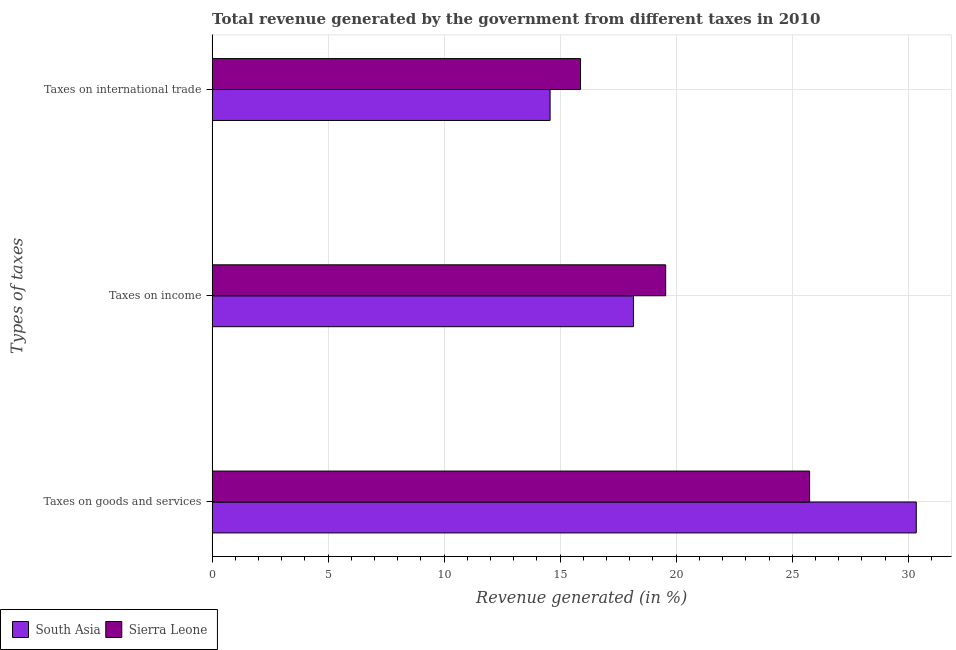How many bars are there on the 3rd tick from the top?
Ensure brevity in your answer.  2. How many bars are there on the 1st tick from the bottom?
Ensure brevity in your answer.  2. What is the label of the 1st group of bars from the top?
Your answer should be very brief. Taxes on international trade. What is the percentage of revenue generated by tax on international trade in South Asia?
Keep it short and to the point. 14.57. Across all countries, what is the maximum percentage of revenue generated by tax on international trade?
Your response must be concise. 15.88. Across all countries, what is the minimum percentage of revenue generated by taxes on income?
Give a very brief answer. 18.16. In which country was the percentage of revenue generated by taxes on income maximum?
Offer a very short reply. Sierra Leone. In which country was the percentage of revenue generated by tax on international trade minimum?
Provide a succinct answer. South Asia. What is the total percentage of revenue generated by tax on international trade in the graph?
Provide a short and direct response. 30.44. What is the difference between the percentage of revenue generated by tax on international trade in South Asia and that in Sierra Leone?
Provide a short and direct response. -1.31. What is the difference between the percentage of revenue generated by taxes on income in South Asia and the percentage of revenue generated by tax on international trade in Sierra Leone?
Give a very brief answer. 2.28. What is the average percentage of revenue generated by taxes on income per country?
Your response must be concise. 18.85. What is the difference between the percentage of revenue generated by tax on international trade and percentage of revenue generated by taxes on goods and services in South Asia?
Provide a short and direct response. -15.78. In how many countries, is the percentage of revenue generated by taxes on income greater than 4 %?
Make the answer very short. 2. What is the ratio of the percentage of revenue generated by taxes on income in Sierra Leone to that in South Asia?
Your answer should be compact. 1.08. What is the difference between the highest and the second highest percentage of revenue generated by tax on international trade?
Make the answer very short. 1.31. What is the difference between the highest and the lowest percentage of revenue generated by taxes on goods and services?
Offer a terse response. 4.6. What does the 1st bar from the top in Taxes on income represents?
Ensure brevity in your answer.  Sierra Leone. What does the 1st bar from the bottom in Taxes on goods and services represents?
Offer a terse response. South Asia. How many bars are there?
Offer a very short reply. 6. How many countries are there in the graph?
Your answer should be compact. 2. Does the graph contain grids?
Give a very brief answer. Yes. What is the title of the graph?
Make the answer very short. Total revenue generated by the government from different taxes in 2010. Does "Yemen, Rep." appear as one of the legend labels in the graph?
Your answer should be compact. No. What is the label or title of the X-axis?
Your response must be concise. Revenue generated (in %). What is the label or title of the Y-axis?
Provide a short and direct response. Types of taxes. What is the Revenue generated (in %) of South Asia in Taxes on goods and services?
Offer a very short reply. 30.35. What is the Revenue generated (in %) in Sierra Leone in Taxes on goods and services?
Offer a terse response. 25.75. What is the Revenue generated (in %) in South Asia in Taxes on income?
Keep it short and to the point. 18.16. What is the Revenue generated (in %) in Sierra Leone in Taxes on income?
Provide a succinct answer. 19.55. What is the Revenue generated (in %) of South Asia in Taxes on international trade?
Provide a short and direct response. 14.57. What is the Revenue generated (in %) of Sierra Leone in Taxes on international trade?
Ensure brevity in your answer.  15.88. Across all Types of taxes, what is the maximum Revenue generated (in %) in South Asia?
Keep it short and to the point. 30.35. Across all Types of taxes, what is the maximum Revenue generated (in %) of Sierra Leone?
Your answer should be very brief. 25.75. Across all Types of taxes, what is the minimum Revenue generated (in %) of South Asia?
Provide a short and direct response. 14.57. Across all Types of taxes, what is the minimum Revenue generated (in %) of Sierra Leone?
Provide a succinct answer. 15.88. What is the total Revenue generated (in %) of South Asia in the graph?
Provide a succinct answer. 63.07. What is the total Revenue generated (in %) of Sierra Leone in the graph?
Make the answer very short. 61.17. What is the difference between the Revenue generated (in %) in South Asia in Taxes on goods and services and that in Taxes on income?
Your response must be concise. 12.19. What is the difference between the Revenue generated (in %) in Sierra Leone in Taxes on goods and services and that in Taxes on income?
Offer a very short reply. 6.2. What is the difference between the Revenue generated (in %) of South Asia in Taxes on goods and services and that in Taxes on international trade?
Ensure brevity in your answer.  15.78. What is the difference between the Revenue generated (in %) in Sierra Leone in Taxes on goods and services and that in Taxes on international trade?
Make the answer very short. 9.87. What is the difference between the Revenue generated (in %) in South Asia in Taxes on income and that in Taxes on international trade?
Keep it short and to the point. 3.59. What is the difference between the Revenue generated (in %) in Sierra Leone in Taxes on income and that in Taxes on international trade?
Provide a short and direct response. 3.67. What is the difference between the Revenue generated (in %) in South Asia in Taxes on goods and services and the Revenue generated (in %) in Sierra Leone in Taxes on income?
Your answer should be compact. 10.8. What is the difference between the Revenue generated (in %) of South Asia in Taxes on goods and services and the Revenue generated (in %) of Sierra Leone in Taxes on international trade?
Offer a terse response. 14.47. What is the difference between the Revenue generated (in %) in South Asia in Taxes on income and the Revenue generated (in %) in Sierra Leone in Taxes on international trade?
Provide a short and direct response. 2.28. What is the average Revenue generated (in %) in South Asia per Types of taxes?
Make the answer very short. 21.02. What is the average Revenue generated (in %) of Sierra Leone per Types of taxes?
Your answer should be compact. 20.39. What is the difference between the Revenue generated (in %) in South Asia and Revenue generated (in %) in Sierra Leone in Taxes on goods and services?
Make the answer very short. 4.6. What is the difference between the Revenue generated (in %) in South Asia and Revenue generated (in %) in Sierra Leone in Taxes on income?
Make the answer very short. -1.39. What is the difference between the Revenue generated (in %) of South Asia and Revenue generated (in %) of Sierra Leone in Taxes on international trade?
Keep it short and to the point. -1.31. What is the ratio of the Revenue generated (in %) in South Asia in Taxes on goods and services to that in Taxes on income?
Offer a very short reply. 1.67. What is the ratio of the Revenue generated (in %) of Sierra Leone in Taxes on goods and services to that in Taxes on income?
Your answer should be very brief. 1.32. What is the ratio of the Revenue generated (in %) of South Asia in Taxes on goods and services to that in Taxes on international trade?
Provide a succinct answer. 2.08. What is the ratio of the Revenue generated (in %) in Sierra Leone in Taxes on goods and services to that in Taxes on international trade?
Provide a succinct answer. 1.62. What is the ratio of the Revenue generated (in %) in South Asia in Taxes on income to that in Taxes on international trade?
Give a very brief answer. 1.25. What is the ratio of the Revenue generated (in %) in Sierra Leone in Taxes on income to that in Taxes on international trade?
Give a very brief answer. 1.23. What is the difference between the highest and the second highest Revenue generated (in %) in South Asia?
Your answer should be very brief. 12.19. What is the difference between the highest and the second highest Revenue generated (in %) of Sierra Leone?
Provide a succinct answer. 6.2. What is the difference between the highest and the lowest Revenue generated (in %) of South Asia?
Make the answer very short. 15.78. What is the difference between the highest and the lowest Revenue generated (in %) of Sierra Leone?
Provide a short and direct response. 9.87. 